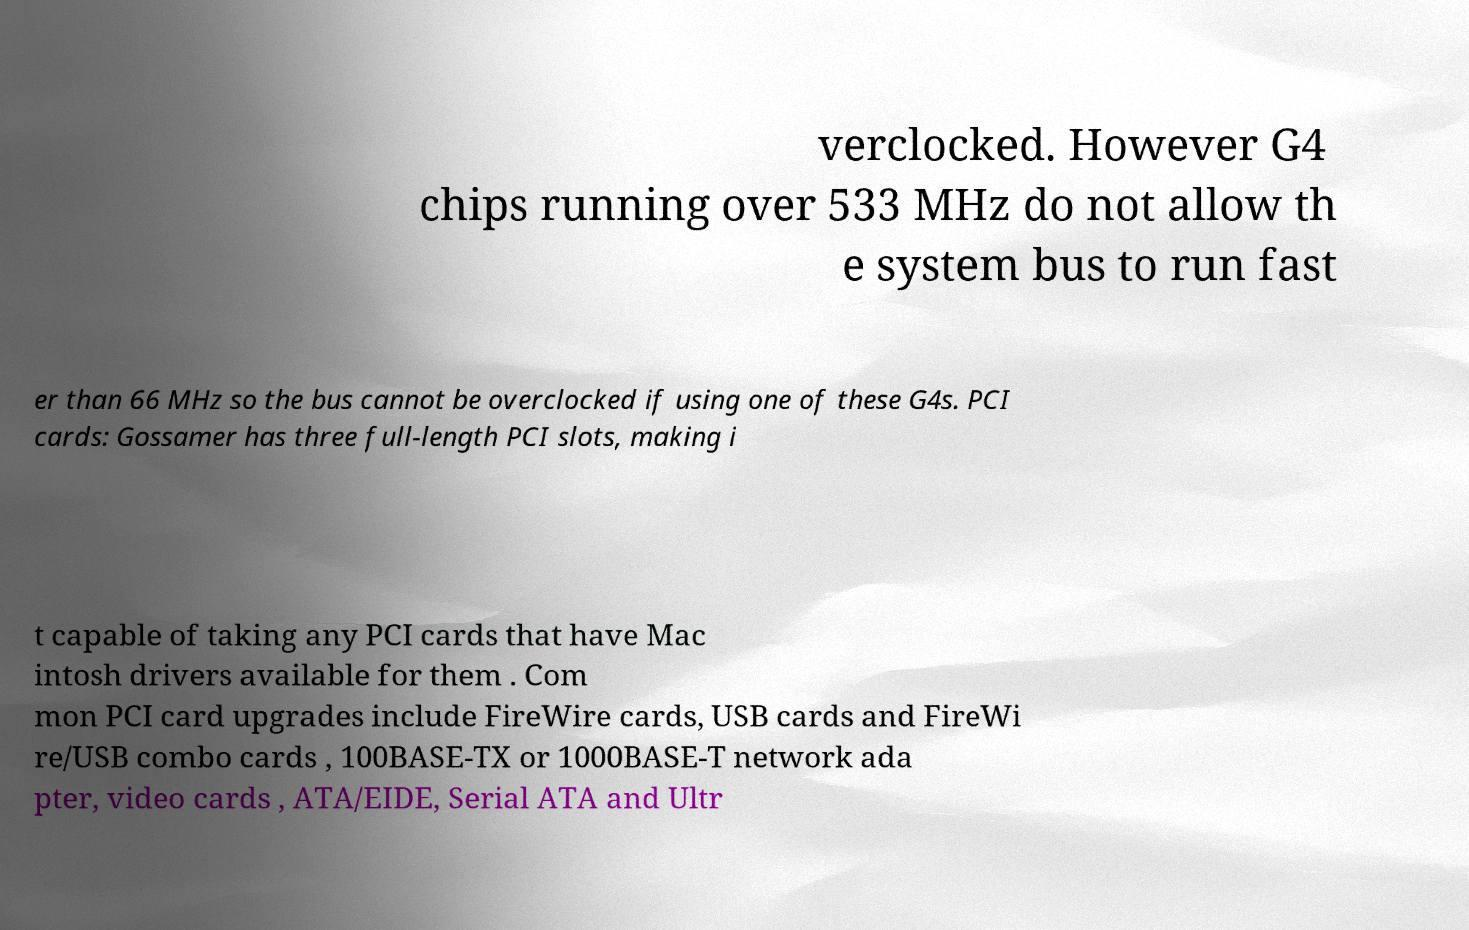Please identify and transcribe the text found in this image. verclocked. However G4 chips running over 533 MHz do not allow th e system bus to run fast er than 66 MHz so the bus cannot be overclocked if using one of these G4s. PCI cards: Gossamer has three full-length PCI slots, making i t capable of taking any PCI cards that have Mac intosh drivers available for them . Com mon PCI card upgrades include FireWire cards, USB cards and FireWi re/USB combo cards , 100BASE-TX or 1000BASE-T network ada pter, video cards , ATA/EIDE, Serial ATA and Ultr 